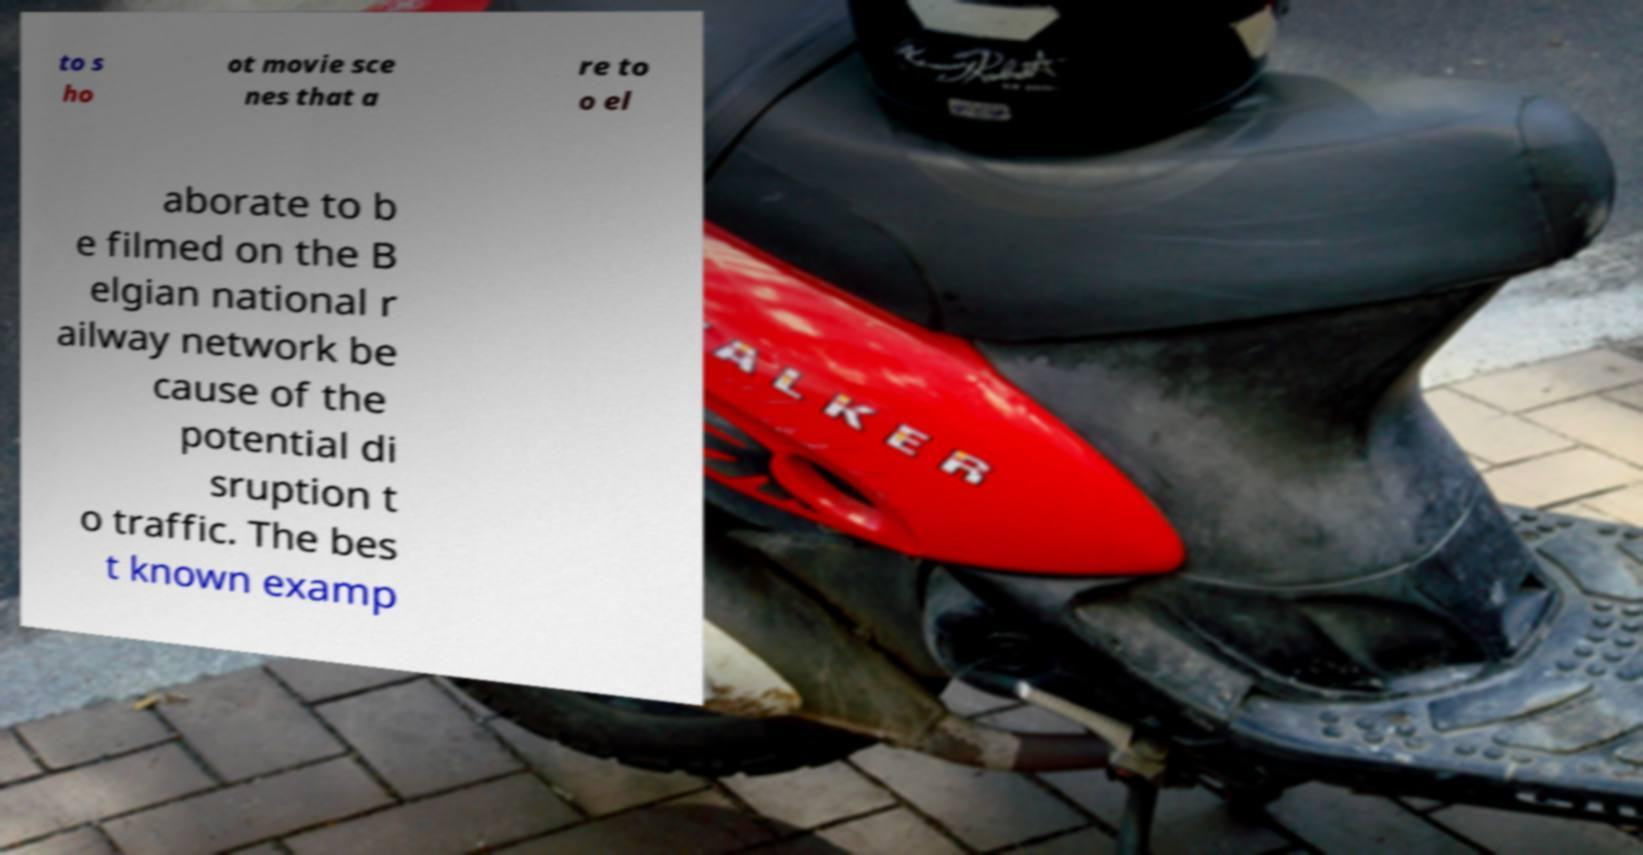What messages or text are displayed in this image? I need them in a readable, typed format. to s ho ot movie sce nes that a re to o el aborate to b e filmed on the B elgian national r ailway network be cause of the potential di sruption t o traffic. The bes t known examp 